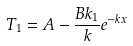<formula> <loc_0><loc_0><loc_500><loc_500>T _ { 1 } = A - \frac { B k _ { 1 } } { k } e ^ { - k x }</formula> 